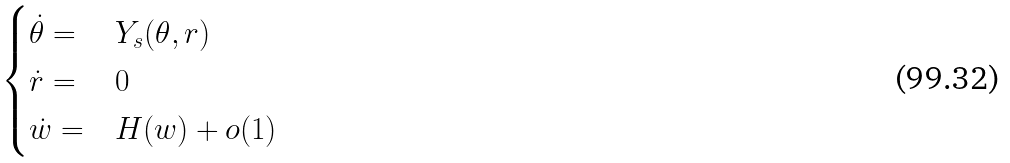Convert formula to latex. <formula><loc_0><loc_0><loc_500><loc_500>\begin{cases} \dot { \theta } = & Y _ { s } ( \theta , r ) \\ \dot { r } = & 0 \\ \dot { w } = & H ( w ) + o ( 1 ) \end{cases}</formula> 